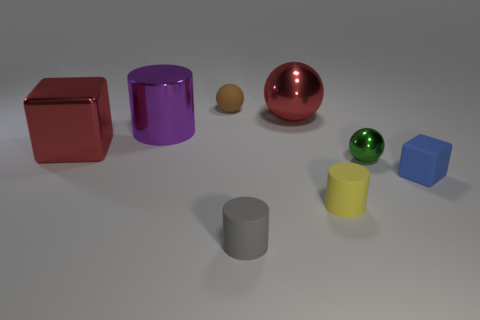What shape is the large metal thing that is the same color as the metallic cube?
Make the answer very short. Sphere. Is the number of rubber cylinders to the right of the gray rubber thing greater than the number of gray blocks?
Ensure brevity in your answer.  Yes. How many other things are made of the same material as the tiny blue cube?
Provide a succinct answer. 3. How many tiny things are either purple matte spheres or shiny cylinders?
Ensure brevity in your answer.  0. Is the material of the blue block the same as the purple cylinder?
Your answer should be compact. No. There is a metal ball behind the small green metal sphere; how many purple shiny things are behind it?
Your answer should be very brief. 0. Is there a large thing of the same shape as the tiny gray object?
Make the answer very short. Yes. There is a red thing behind the purple thing; is its shape the same as the small matte object that is behind the small cube?
Offer a very short reply. Yes. There is a object that is both to the right of the tiny gray cylinder and behind the purple object; what shape is it?
Ensure brevity in your answer.  Sphere. Is there a metal thing of the same size as the metal cylinder?
Make the answer very short. Yes. 